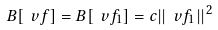Convert formula to latex. <formula><loc_0><loc_0><loc_500><loc_500>B [ \ v f ] = B [ \ v f _ { 1 } ] = c | | \ v f _ { 1 } | | ^ { 2 }</formula> 